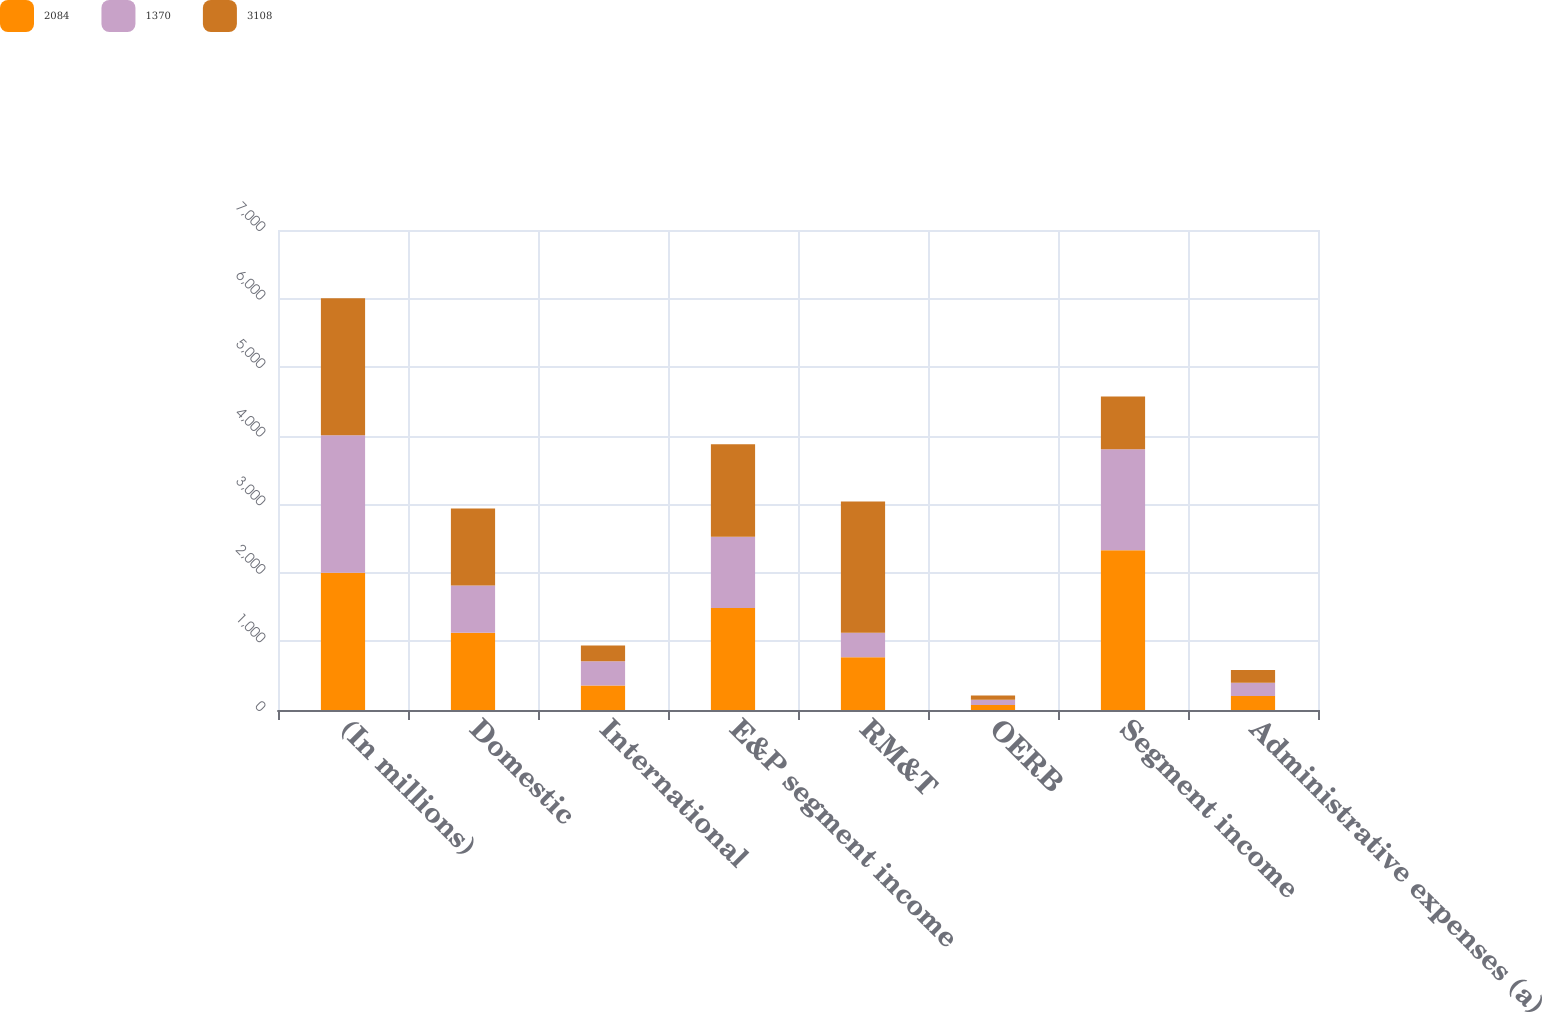Convert chart. <chart><loc_0><loc_0><loc_500><loc_500><stacked_bar_chart><ecel><fcel>(In millions)<fcel>Domestic<fcel>International<fcel>E&P segment income<fcel>RM&T<fcel>OERB<fcel>Segment income<fcel>Administrative expenses (a)<nl><fcel>2084<fcel>2003<fcel>1128<fcel>359<fcel>1487<fcel>770<fcel>73<fcel>2330<fcel>203<nl><fcel>1370<fcel>2002<fcel>687<fcel>351<fcel>1038<fcel>356<fcel>78<fcel>1472<fcel>194<nl><fcel>3108<fcel>2001<fcel>1122<fcel>229<fcel>1351<fcel>1914<fcel>62<fcel>770<fcel>187<nl></chart> 